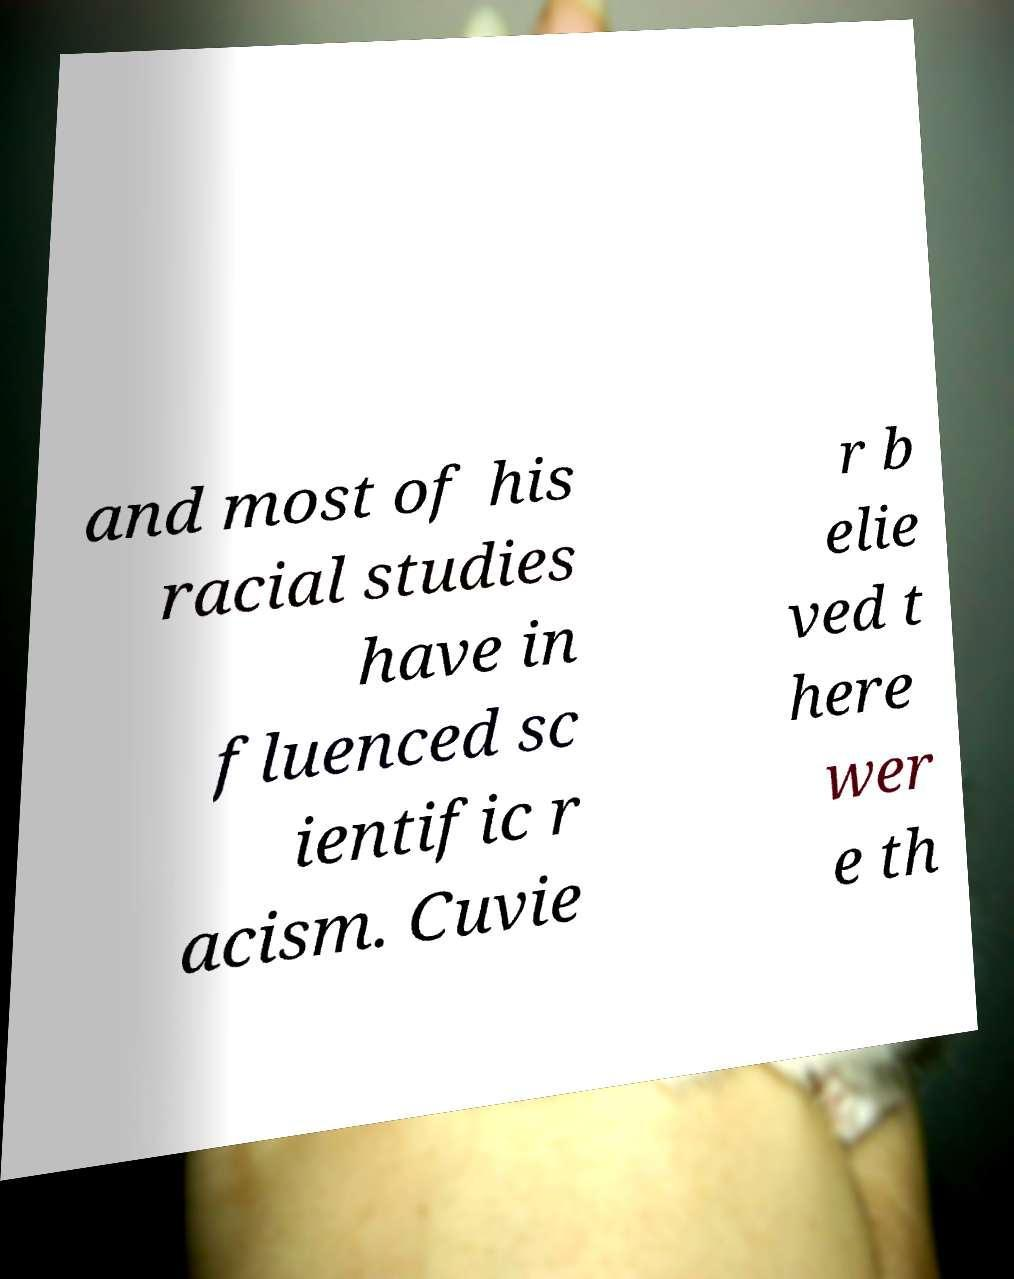Please identify and transcribe the text found in this image. and most of his racial studies have in fluenced sc ientific r acism. Cuvie r b elie ved t here wer e th 